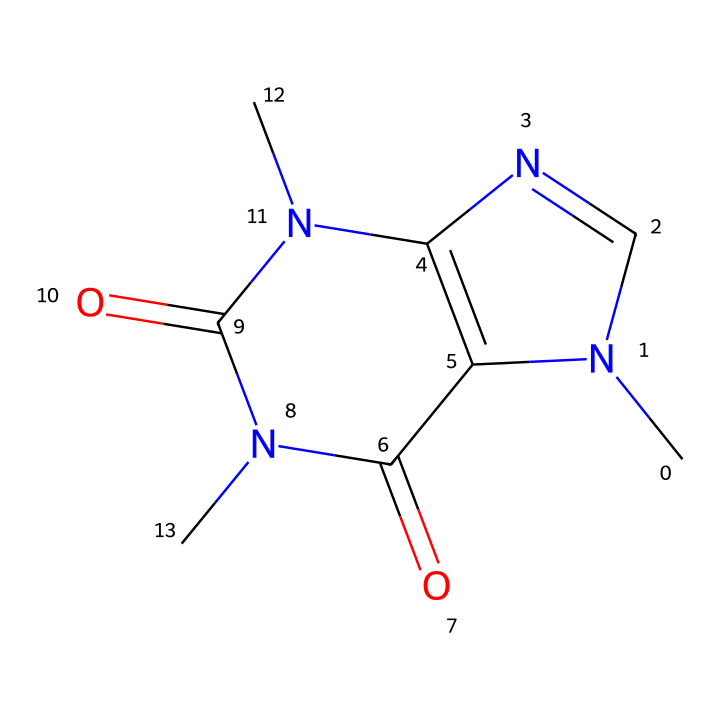What is the molecular formula of caffeine based on its SMILES representation? The SMILES notation can be broken down to identify the number of carbon (C), hydrogen (H), nitrogen (N), and oxygen (O) atoms present. Counting from the structure, caffeine contains 8 carbon atoms, 10 hydrogen atoms, 4 nitrogen atoms, and 2 oxygen atoms, leading to the molecular formula C8H10N4O2.
Answer: C8H10N4O2 How many nitrogen atoms are present in the caffeine molecule? Looking closely at the SMILES structure, we can count the nitrogen atoms represented by the letter "N". There are a total of 4 nitrogen atoms present in the caffeine structure.
Answer: 4 What type of functional groups can be identified in caffeine? By analyzing the structure, we find amine groups (identified by the nitrogen atoms) and carbonyl groups (identified by the carbon-oxygen double bonds). Both of these play important roles in the behavior of caffeine.
Answer: amine and carbonyl How many rings are present in the caffeine structure? The structure contains two interconnected rings formed by the arrangement of carbon and nitrogen atoms that contribute to its bicyclic nature. This can be visually assessed by observing the cyclic structure within the SMILES.
Answer: 2 What property does the presence of nitrogen atoms in caffeine suggest about its chemical nature? The presence of nitrogen atoms, particularly in cyclic and amine forms, suggests that caffeine is an alkaloid, a class of compounds known for their pharmacological effects. This classification can be derived directly from the nitrogen atoms and their arrangement in the molecule.
Answer: alkaloid 